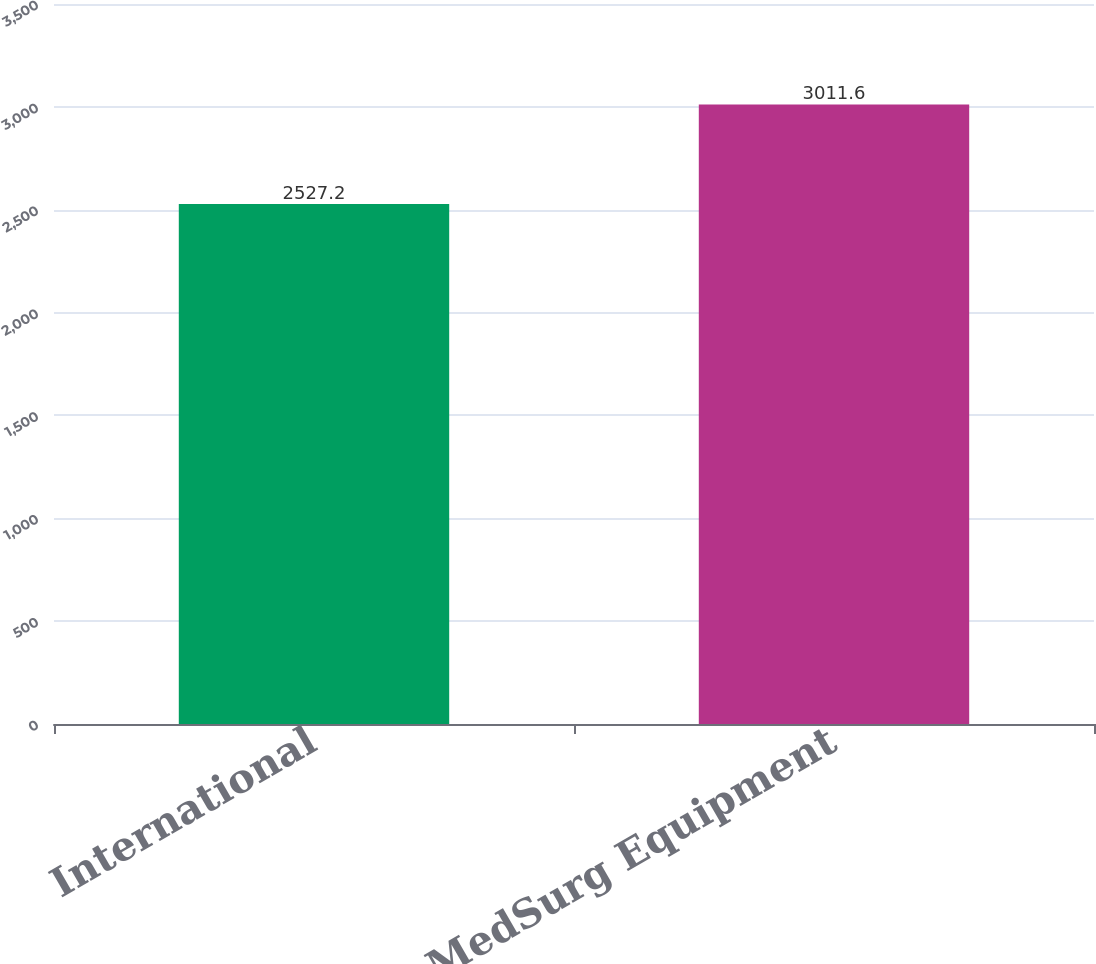Convert chart. <chart><loc_0><loc_0><loc_500><loc_500><bar_chart><fcel>International<fcel>MedSurg Equipment<nl><fcel>2527.2<fcel>3011.6<nl></chart> 